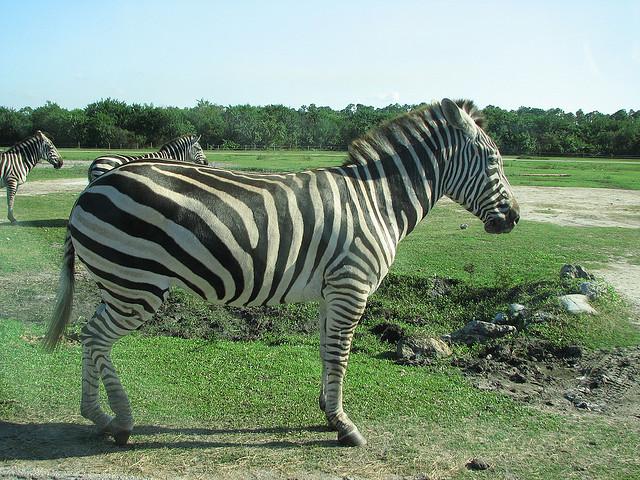Based on the shadows, is it most likely mid-day or afternoon?
Keep it brief. Afternoon. Is the zebra eating the grass?
Short answer required. No. Is the zebra standing in full sun?
Keep it brief. Yes. What landforms are in the background of this picture?
Answer briefly. Trees. What is this animal?
Quick response, please. Zebra. What animal is laying on the ground?
Quick response, please. None. Is there a mountain in the background?
Quick response, please. No. What are the zebras eating?
Quick response, please. Grass. What are the zebras doing?
Concise answer only. Standing. Is the zebra walking or standing still?
Answer briefly. Standing still. What direction is the zebra facing?
Write a very short answer. Right. Are all the zebras facing to the right?
Be succinct. Yes. What color stripe in the middle of his back stands out?
Quick response, please. Black. What is in the background?
Give a very brief answer. Trees. 